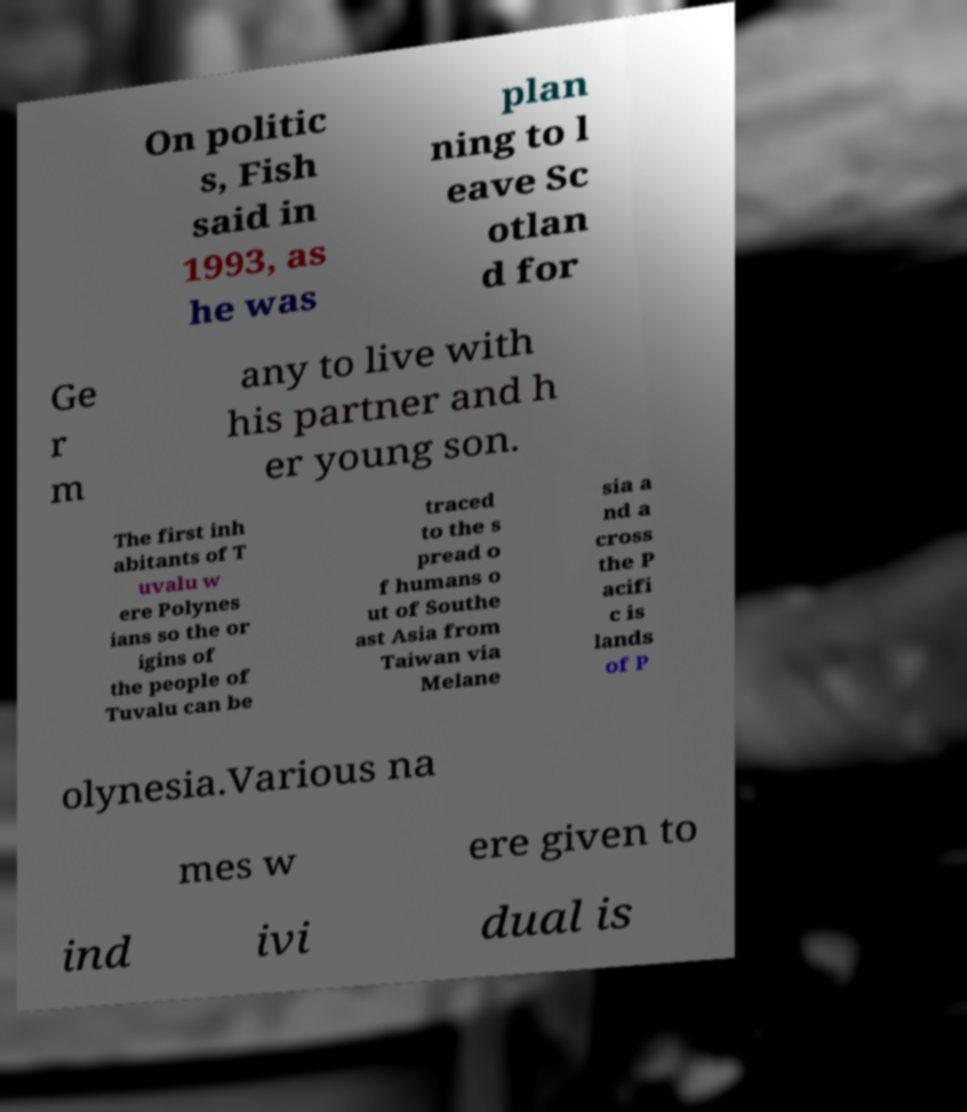I need the written content from this picture converted into text. Can you do that? On politic s, Fish said in 1993, as he was plan ning to l eave Sc otlan d for Ge r m any to live with his partner and h er young son. The first inh abitants of T uvalu w ere Polynes ians so the or igins of the people of Tuvalu can be traced to the s pread o f humans o ut of Southe ast Asia from Taiwan via Melane sia a nd a cross the P acifi c is lands of P olynesia.Various na mes w ere given to ind ivi dual is 